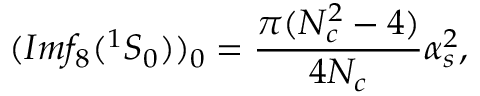Convert formula to latex. <formula><loc_0><loc_0><loc_500><loc_500>( I m f _ { 8 } ( ^ { 1 } S _ { 0 } ) ) _ { 0 } = \frac { \pi ( N _ { c } ^ { 2 } - 4 ) } { 4 N _ { c } } \alpha _ { s } ^ { 2 } ,</formula> 